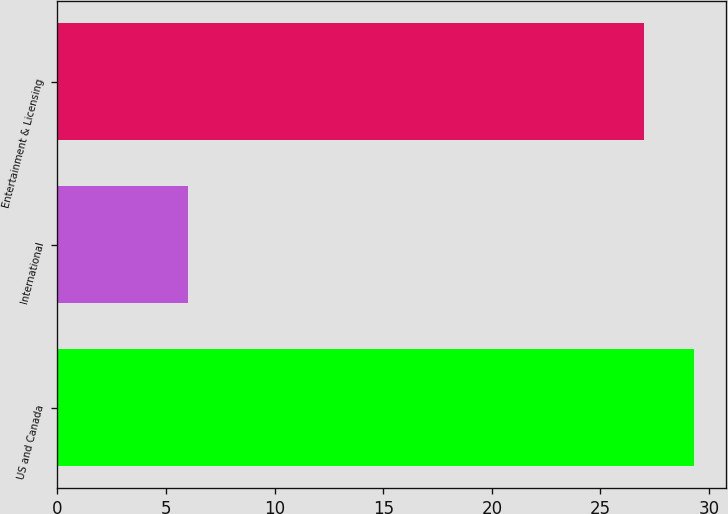Convert chart to OTSL. <chart><loc_0><loc_0><loc_500><loc_500><bar_chart><fcel>US and Canada<fcel>International<fcel>Entertainment & Licensing<nl><fcel>29.3<fcel>6<fcel>27<nl></chart> 